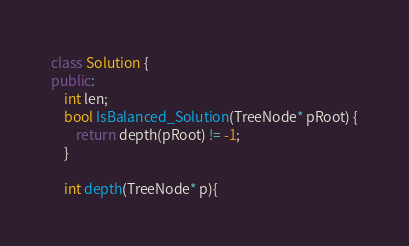Convert code to text. <code><loc_0><loc_0><loc_500><loc_500><_C++_>class Solution {
public:
    int len;
    bool IsBalanced_Solution(TreeNode* pRoot) {
        return depth(pRoot) != -1;
    }
    
    int depth(TreeNode* p){</code> 